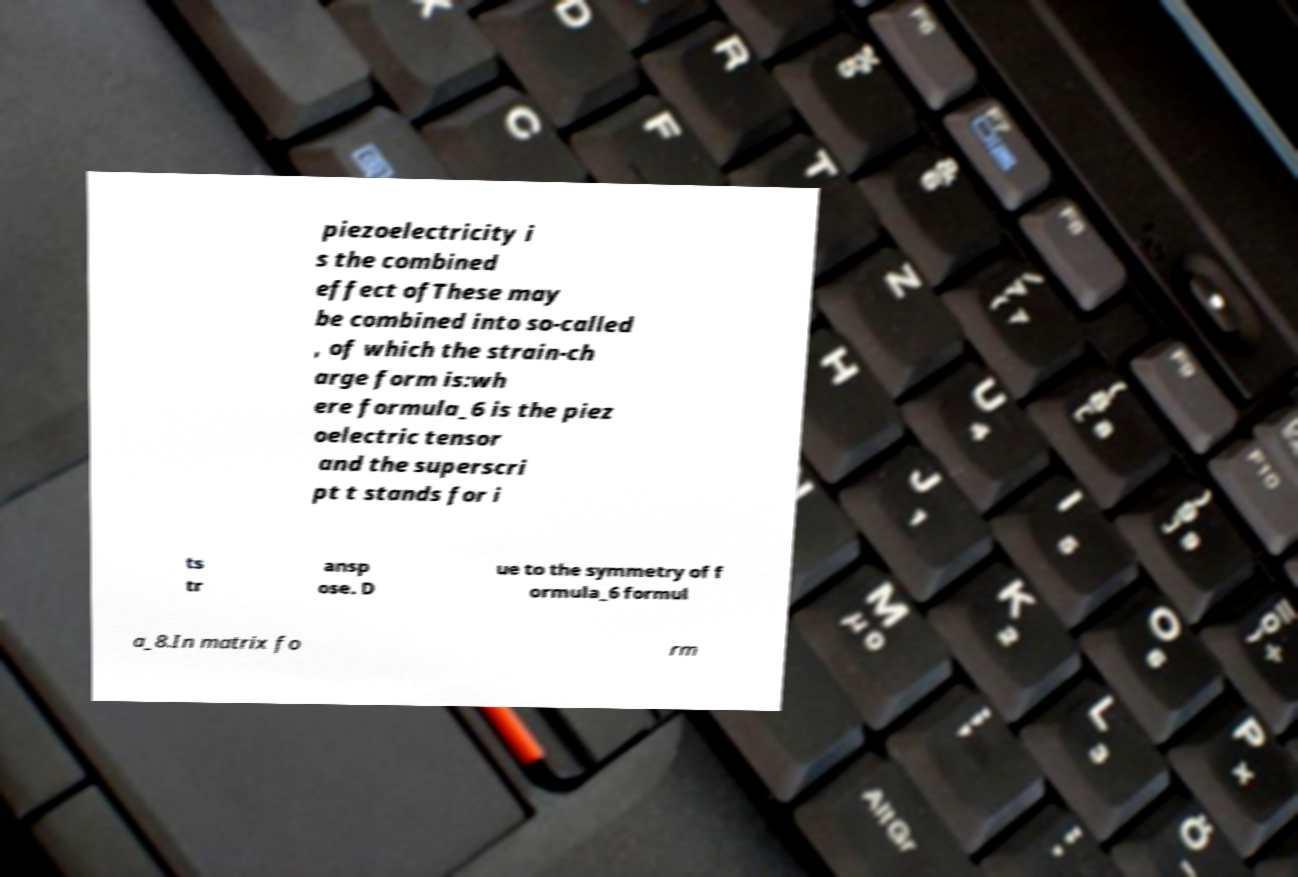Please read and relay the text visible in this image. What does it say? piezoelectricity i s the combined effect ofThese may be combined into so-called , of which the strain-ch arge form is:wh ere formula_6 is the piez oelectric tensor and the superscri pt t stands for i ts tr ansp ose. D ue to the symmetry of f ormula_6 formul a_8.In matrix fo rm 